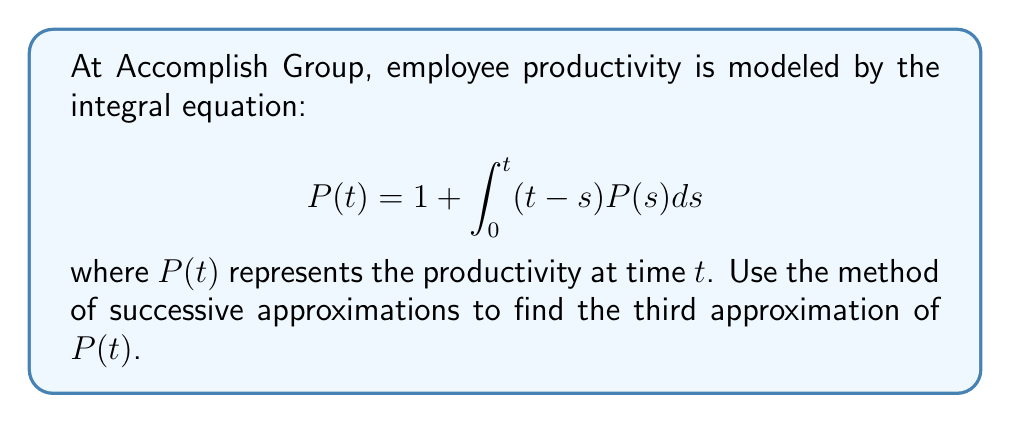Solve this math problem. Let's apply the method of successive approximations:

1) Start with the initial approximation $P_0(t) = 1$

2) For the first approximation:
   $$P_1(t) = 1 + \int_0^t (t-s)P_0(s)ds = 1 + \int_0^t (t-s)ds = 1 + [ts - \frac{s^2}{2}]_0^t = 1 + t^2 - \frac{t^2}{2} = 1 + \frac{t^2}{2}$$

3) For the second approximation:
   $$\begin{align*}
   P_2(t) &= 1 + \int_0^t (t-s)P_1(s)ds \\
   &= 1 + \int_0^t (t-s)(1 + \frac{s^2}{2})ds \\
   &= 1 + \int_0^t (t-s + \frac{ts^2}{2} - \frac{s^3}{2})ds \\
   &= 1 + [ts - \frac{s^2}{2} + \frac{ts^3}{6} - \frac{s^4}{8}]_0^t \\
   &= 1 + t^2 - \frac{t^2}{2} + \frac{t^4}{6} - \frac{t^4}{8} \\
   &= 1 + \frac{t^2}{2} + \frac{t^4}{24}
   \end{align*}$$

4) For the third approximation:
   $$\begin{align*}
   P_3(t) &= 1 + \int_0^t (t-s)P_2(s)ds \\
   &= 1 + \int_0^t (t-s)(1 + \frac{s^2}{2} + \frac{s^4}{24})ds \\
   &= 1 + \int_0^t (t-s + \frac{ts^2}{2} - \frac{s^3}{2} + \frac{ts^4}{24} - \frac{s^5}{24})ds \\
   &= 1 + [ts - \frac{s^2}{2} + \frac{ts^3}{6} - \frac{s^4}{8} + \frac{ts^5}{120} - \frac{s^6}{144}]_0^t \\
   &= 1 + t^2 - \frac{t^2}{2} + \frac{t^4}{6} - \frac{t^4}{8} + \frac{t^6}{120} - \frac{t^6}{144} \\
   &= 1 + \frac{t^2}{2} + \frac{t^4}{24} + \frac{t^6}{720}
   \end{align*}$$
Answer: $P_3(t) = 1 + \frac{t^2}{2} + \frac{t^4}{24} + \frac{t^6}{720}$ 